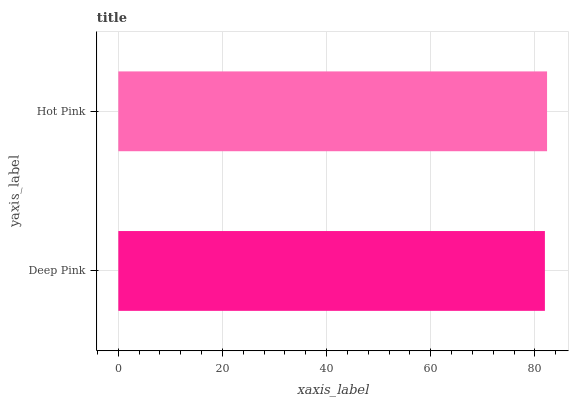Is Deep Pink the minimum?
Answer yes or no. Yes. Is Hot Pink the maximum?
Answer yes or no. Yes. Is Hot Pink the minimum?
Answer yes or no. No. Is Hot Pink greater than Deep Pink?
Answer yes or no. Yes. Is Deep Pink less than Hot Pink?
Answer yes or no. Yes. Is Deep Pink greater than Hot Pink?
Answer yes or no. No. Is Hot Pink less than Deep Pink?
Answer yes or no. No. Is Hot Pink the high median?
Answer yes or no. Yes. Is Deep Pink the low median?
Answer yes or no. Yes. Is Deep Pink the high median?
Answer yes or no. No. Is Hot Pink the low median?
Answer yes or no. No. 